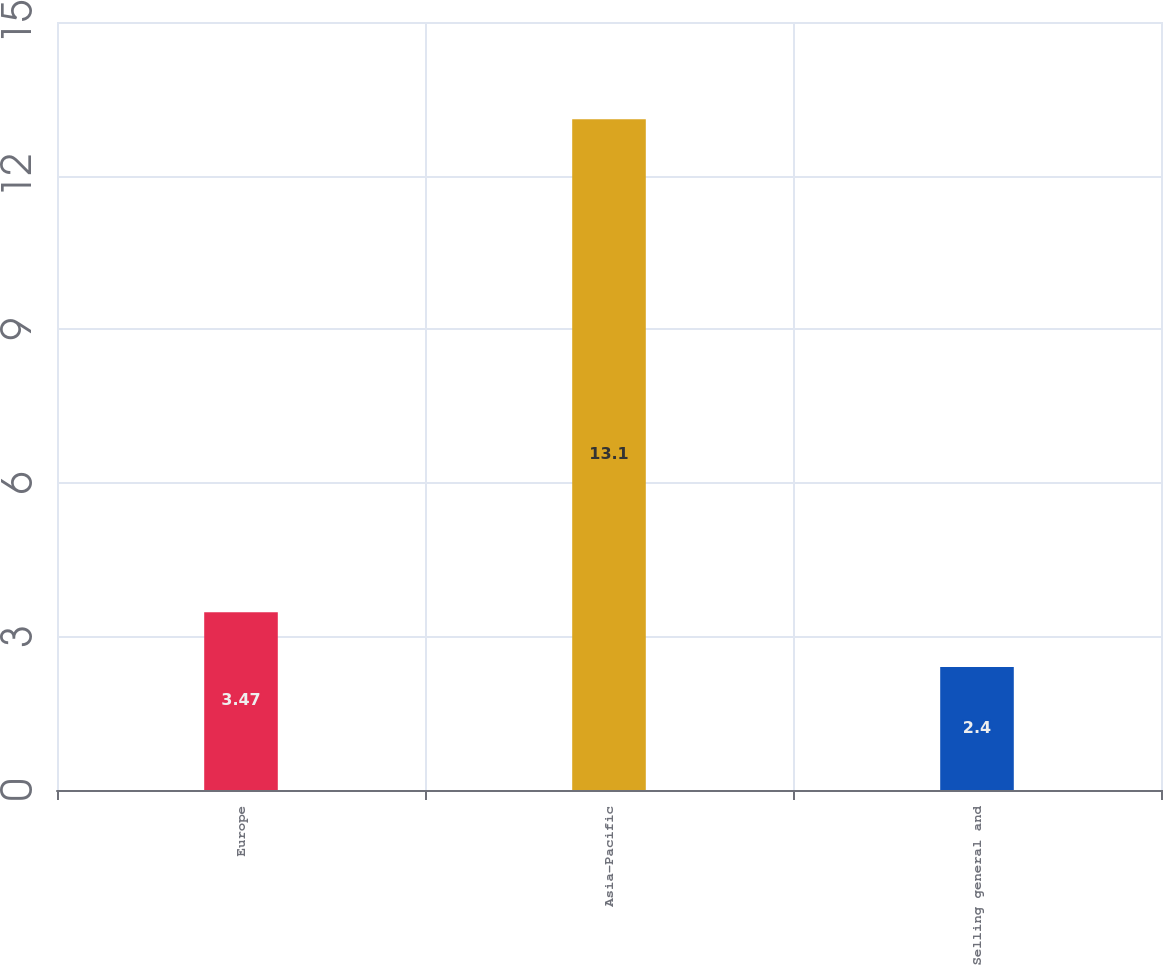<chart> <loc_0><loc_0><loc_500><loc_500><bar_chart><fcel>Europe<fcel>Asia-Pacific<fcel>Selling general and<nl><fcel>3.47<fcel>13.1<fcel>2.4<nl></chart> 